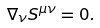<formula> <loc_0><loc_0><loc_500><loc_500>\nabla _ { \nu } S ^ { \mu \nu } = 0 .</formula> 